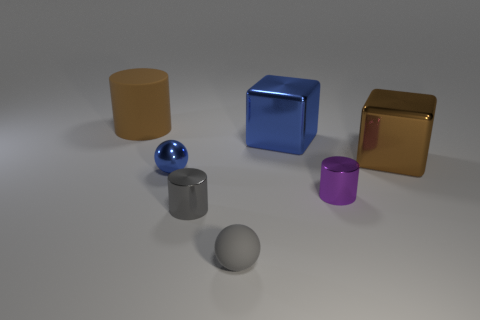Can you describe the shapes and their colors in the image? Certainly! In the image, there are five different shapes, each with a unique color. From left to right, there is a beige cylinder, a bright blue cube, a glossy blue sphere, a dark gray cylinder, and a purple cylinder. Additionally, there is a shiny gold cube. 